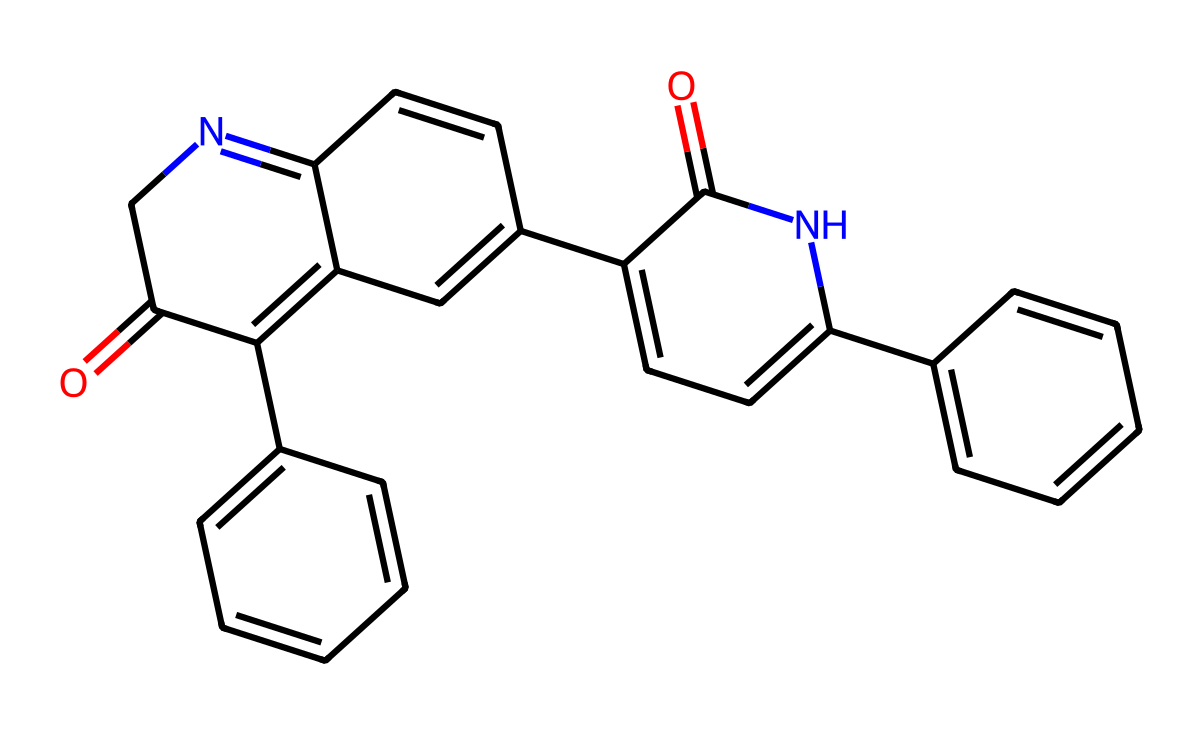How many nitrogen atoms are present in the structure? The structure can be analyzed for its elements, and by counting the nitrogen atoms indicated in the SMILES, we find that there are two nitrogen atoms included in the complex.
Answer: two What is the molecular weight of indigo dye? To determine the molecular weight, the weights of all atoms in the structure must be summed. For indigo dye represented by this SMILES, the total is calculated to be around 262.25 g/mol.
Answer: 262.25 Which type of bond predominates in this indigo dye structure? By examining the structure’s connectivity, it is evident that the predominant bond type is covalent, as the compound consists of a network of atoms bonded through shared electron pairs.
Answer: covalent What functional groups are present in the indigo dye? Upon analyzing the structure, we can identify that the primary functional groups are amides and aromatic rings, shown by the presence of -NC=O groups and cyclic carbon configurations.
Answer: amide, aromatic How many rings are in the indigo dye structure? Observing the complex structure and recognizing the cyclical formations, it is noted that there are four distinct aromatic rings incorporated into the indigo dye structure.
Answer: four What property makes indigo suitable for dyeing soccer jerseys? The substantial colorfastness of indigo, due to its stable chemical structure and ability to withstand washing, is what primarily makes it suitable for dyeing soccer jerseys.
Answer: colorfastness 